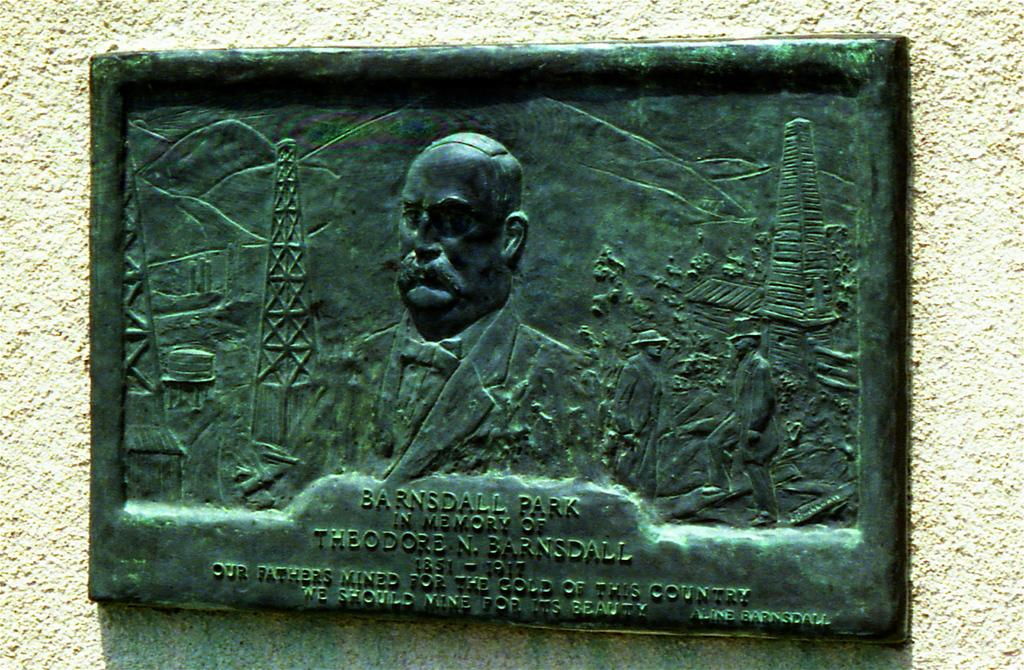What is the main object in the image? There is a stele in the image. What is the color of the stele? The stele is black in color. What can be found at the bottom of the stele? There is text written at the bottom of the stele. What is visible in the background of the image? There is a wall in the background of the image. How many screws are holding the stele to the wall in the image? There are no screws visible in the image, as the stele is not attached to the wall. 